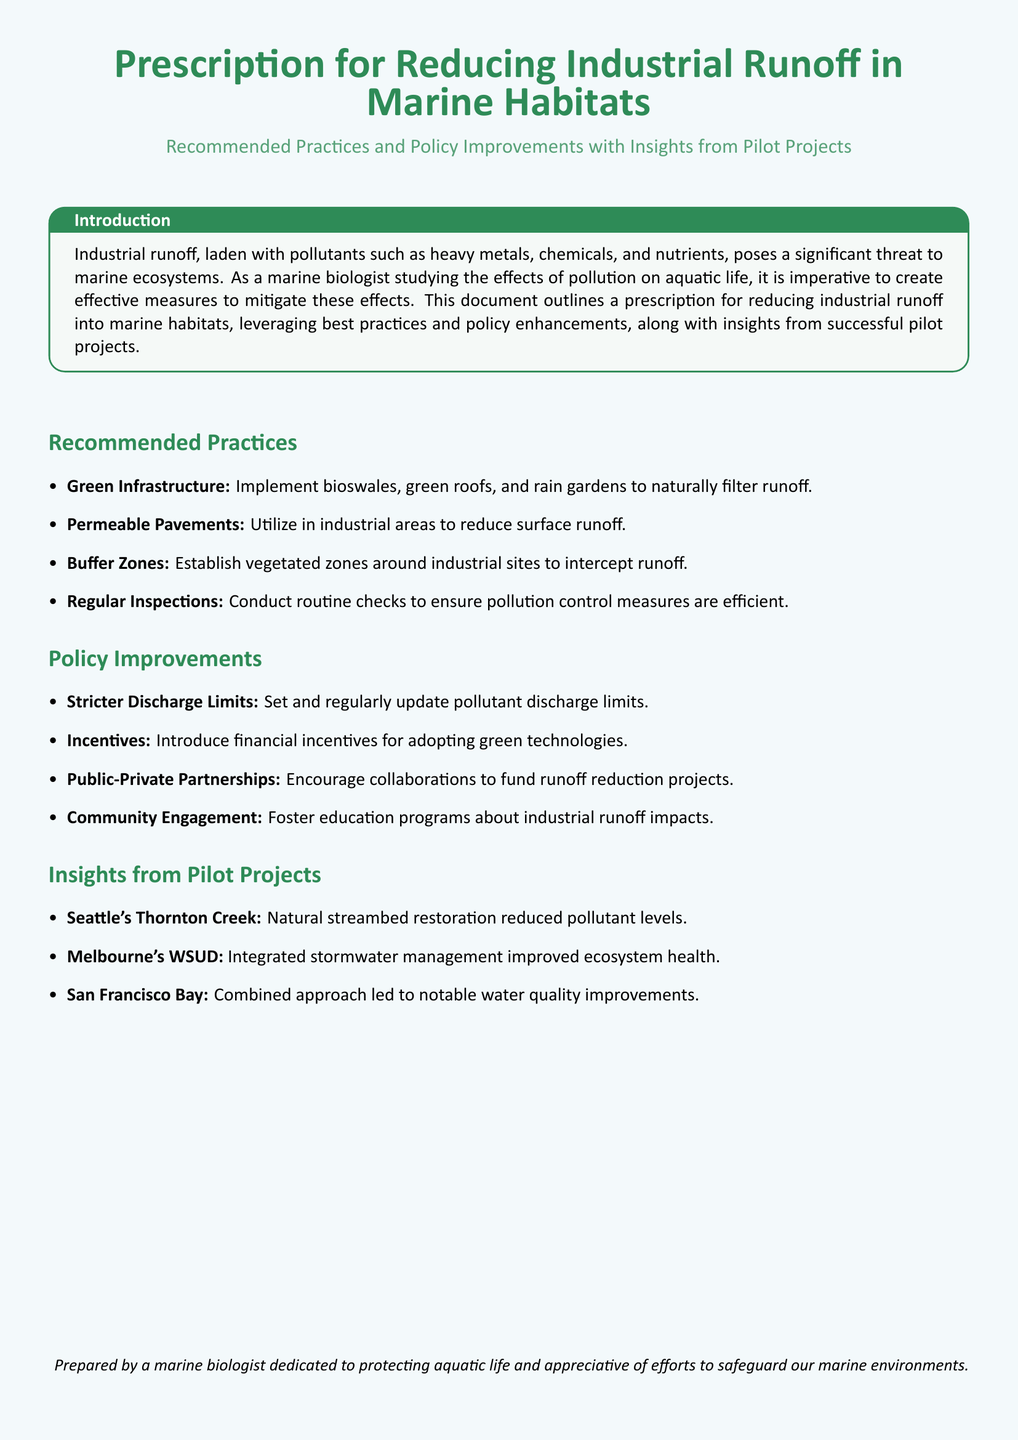What is the main threat posed by industrial runoff? The document states that industrial runoff poses a significant threat to marine ecosystems due to pollutants such as heavy metals, chemicals, and nutrients.
Answer: Marine ecosystems What practice involves the use of bioswales? The implementation of green infrastructure, which includes bioswales, is mentioned as a recommended practice to filter runoff naturally.
Answer: Green Infrastructure What city is associated with natural streambed restoration? The pilot project in Seattle focusing on natural streambed restoration is mentioned in the document.
Answer: Seattle How many recommended practices are listed in the document? The document details four recommended practices for reducing industrial runoff.
Answer: Four What is one proposed policy change to address industrial runoff? The document suggests introducing stricter discharge limits as a policy improvement for managing industrial runoff.
Answer: Stricter Discharge Limits Which pilot project improved ecosystem health through stormwater management? Melbourne's WSUD is highlighted in the document as successfully improving ecosystem health through integrated stormwater management.
Answer: Melbourne's WSUD What is suggested to foster community awareness about industrial runoff impacts? The document recommends community engagement through education programs to raise awareness about the impacts of industrial runoff.
Answer: Education programs What is the purpose of establishing buffer zones? Buffer zones are recommended to be established around industrial sites to intercept runoff before it enters marine habitats.
Answer: Intercept runoff 